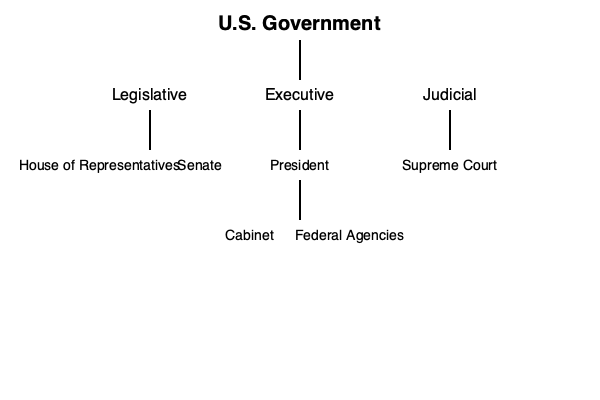Based on the tree diagram of the U.S. government structure, which branch has the most direct subdivisions, and what are they? How does this branch's structure contribute to the system of checks and balances? To answer this question, let's analyze the tree diagram step-by-step:

1. The diagram shows three main branches of the U.S. government: Legislative, Executive, and Judicial.

2. The Legislative branch is divided into two parts:
   - House of Representatives
   - Senate

3. The Executive branch has three subdivisions:
   - President
   - Cabinet
   - Federal Agencies

4. The Judicial branch is represented only by the Supreme Court in this diagram.

5. Comparing the number of direct subdivisions:
   - Legislative: 2
   - Executive: 3
   - Judicial: 1

6. The Executive branch has the most direct subdivisions with 3.

7. The structure of the Executive branch contributes to the system of checks and balances in several ways:
   a. The President, as head of the Executive branch, can veto laws passed by the Legislative branch.
   b. The President nominates Supreme Court justices and other federal judges, but these nominations must be confirmed by the Senate (part of the Legislative branch).
   c. The Cabinet and Federal Agencies implement and enforce laws passed by Congress, but their actions can be reviewed and potentially overturned by the Judicial branch.
   d. The separation of the Cabinet and Federal Agencies from the President allows for some independence in policy implementation and enforcement, providing internal checks within the Executive branch itself.

This structure ensures that power is distributed and balanced among different entities within the Executive branch and across the three branches of government.
Answer: Executive branch (President, Cabinet, Federal Agencies); it enables internal checks and inter-branch balance of power. 